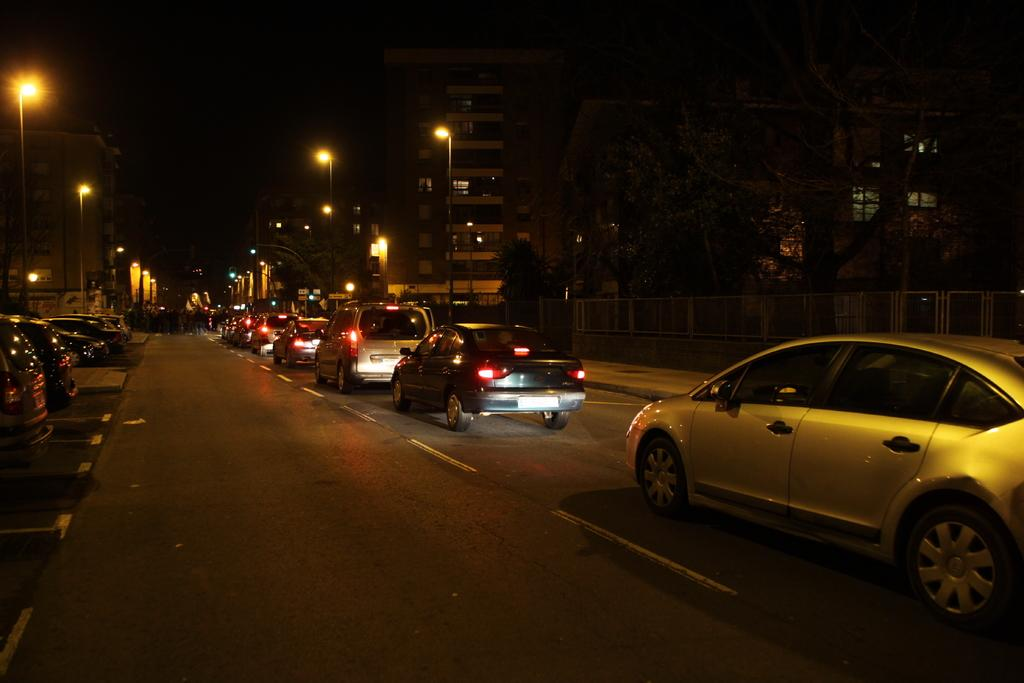What time of day is depicted in the image? The image depicts a night view. What can be seen on the road in the image? There are vehicles on the road in the image. What type of natural elements are present in the image? There are trees in the image. What type of man-made structures are present in the image? There are buildings in the image. What type of barrier can be seen in the image? There is a fence visible in the image. What type of lighting is present in the image? There are street lights in the image. What type of nail is being hammered into the tree in the image? There is no nail being hammered into the tree in the image; there are no people or tools present. Can you see any fish swimming in the image? There are no fish visible in the image; it depicts a night view of a road, trees, buildings, and street lights. 